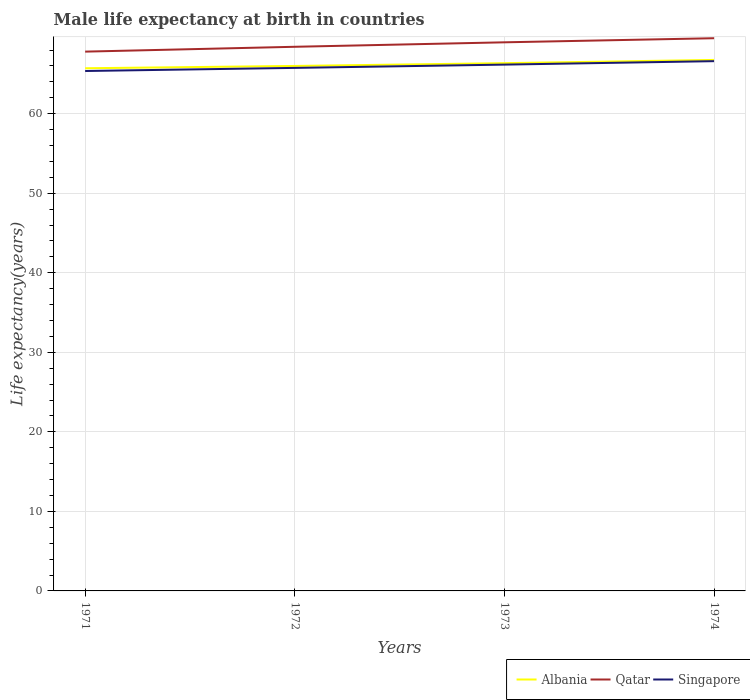Does the line corresponding to Singapore intersect with the line corresponding to Qatar?
Give a very brief answer. No. Across all years, what is the maximum male life expectancy at birth in Singapore?
Your answer should be very brief. 65.37. What is the total male life expectancy at birth in Qatar in the graph?
Keep it short and to the point. -1.08. What is the difference between the highest and the second highest male life expectancy at birth in Singapore?
Your answer should be very brief. 1.24. What is the difference between the highest and the lowest male life expectancy at birth in Qatar?
Offer a very short reply. 2. Is the male life expectancy at birth in Qatar strictly greater than the male life expectancy at birth in Albania over the years?
Offer a terse response. No. How many lines are there?
Your answer should be very brief. 3. How many years are there in the graph?
Provide a short and direct response. 4. Does the graph contain any zero values?
Give a very brief answer. No. Where does the legend appear in the graph?
Your answer should be very brief. Bottom right. How many legend labels are there?
Your answer should be very brief. 3. What is the title of the graph?
Your answer should be compact. Male life expectancy at birth in countries. What is the label or title of the X-axis?
Offer a very short reply. Years. What is the label or title of the Y-axis?
Make the answer very short. Life expectancy(years). What is the Life expectancy(years) of Albania in 1971?
Ensure brevity in your answer.  65.71. What is the Life expectancy(years) of Qatar in 1971?
Provide a succinct answer. 67.8. What is the Life expectancy(years) in Singapore in 1971?
Give a very brief answer. 65.37. What is the Life expectancy(years) in Albania in 1972?
Ensure brevity in your answer.  66. What is the Life expectancy(years) in Qatar in 1972?
Your response must be concise. 68.41. What is the Life expectancy(years) of Singapore in 1972?
Give a very brief answer. 65.76. What is the Life expectancy(years) in Albania in 1973?
Provide a succinct answer. 66.36. What is the Life expectancy(years) in Qatar in 1973?
Provide a succinct answer. 68.97. What is the Life expectancy(years) in Singapore in 1973?
Provide a succinct answer. 66.17. What is the Life expectancy(years) of Albania in 1974?
Provide a succinct answer. 66.76. What is the Life expectancy(years) of Qatar in 1974?
Offer a very short reply. 69.49. What is the Life expectancy(years) of Singapore in 1974?
Provide a succinct answer. 66.61. Across all years, what is the maximum Life expectancy(years) in Albania?
Provide a succinct answer. 66.76. Across all years, what is the maximum Life expectancy(years) of Qatar?
Your answer should be compact. 69.49. Across all years, what is the maximum Life expectancy(years) in Singapore?
Ensure brevity in your answer.  66.61. Across all years, what is the minimum Life expectancy(years) of Albania?
Offer a very short reply. 65.71. Across all years, what is the minimum Life expectancy(years) of Qatar?
Keep it short and to the point. 67.8. Across all years, what is the minimum Life expectancy(years) of Singapore?
Make the answer very short. 65.37. What is the total Life expectancy(years) of Albania in the graph?
Your response must be concise. 264.84. What is the total Life expectancy(years) in Qatar in the graph?
Provide a short and direct response. 274.68. What is the total Life expectancy(years) in Singapore in the graph?
Provide a short and direct response. 263.91. What is the difference between the Life expectancy(years) of Albania in 1971 and that in 1972?
Your answer should be very brief. -0.29. What is the difference between the Life expectancy(years) of Qatar in 1971 and that in 1972?
Offer a terse response. -0.61. What is the difference between the Life expectancy(years) in Singapore in 1971 and that in 1972?
Your answer should be compact. -0.39. What is the difference between the Life expectancy(years) of Albania in 1971 and that in 1973?
Provide a succinct answer. -0.64. What is the difference between the Life expectancy(years) of Qatar in 1971 and that in 1973?
Offer a terse response. -1.17. What is the difference between the Life expectancy(years) of Singapore in 1971 and that in 1973?
Offer a very short reply. -0.8. What is the difference between the Life expectancy(years) of Albania in 1971 and that in 1974?
Make the answer very short. -1.05. What is the difference between the Life expectancy(years) in Qatar in 1971 and that in 1974?
Provide a short and direct response. -1.69. What is the difference between the Life expectancy(years) of Singapore in 1971 and that in 1974?
Your answer should be very brief. -1.24. What is the difference between the Life expectancy(years) of Albania in 1972 and that in 1973?
Give a very brief answer. -0.35. What is the difference between the Life expectancy(years) of Qatar in 1972 and that in 1973?
Ensure brevity in your answer.  -0.56. What is the difference between the Life expectancy(years) of Singapore in 1972 and that in 1973?
Keep it short and to the point. -0.41. What is the difference between the Life expectancy(years) of Albania in 1972 and that in 1974?
Give a very brief answer. -0.76. What is the difference between the Life expectancy(years) of Qatar in 1972 and that in 1974?
Your answer should be compact. -1.08. What is the difference between the Life expectancy(years) of Singapore in 1972 and that in 1974?
Make the answer very short. -0.85. What is the difference between the Life expectancy(years) of Albania in 1973 and that in 1974?
Provide a short and direct response. -0.41. What is the difference between the Life expectancy(years) of Qatar in 1973 and that in 1974?
Provide a succinct answer. -0.52. What is the difference between the Life expectancy(years) in Singapore in 1973 and that in 1974?
Provide a short and direct response. -0.43. What is the difference between the Life expectancy(years) of Albania in 1971 and the Life expectancy(years) of Qatar in 1972?
Offer a very short reply. -2.7. What is the difference between the Life expectancy(years) of Albania in 1971 and the Life expectancy(years) of Singapore in 1972?
Make the answer very short. -0.04. What is the difference between the Life expectancy(years) in Qatar in 1971 and the Life expectancy(years) in Singapore in 1972?
Provide a succinct answer. 2.04. What is the difference between the Life expectancy(years) in Albania in 1971 and the Life expectancy(years) in Qatar in 1973?
Your response must be concise. -3.26. What is the difference between the Life expectancy(years) of Albania in 1971 and the Life expectancy(years) of Singapore in 1973?
Keep it short and to the point. -0.46. What is the difference between the Life expectancy(years) of Qatar in 1971 and the Life expectancy(years) of Singapore in 1973?
Provide a succinct answer. 1.63. What is the difference between the Life expectancy(years) in Albania in 1971 and the Life expectancy(years) in Qatar in 1974?
Provide a succinct answer. -3.78. What is the difference between the Life expectancy(years) in Albania in 1971 and the Life expectancy(years) in Singapore in 1974?
Your response must be concise. -0.89. What is the difference between the Life expectancy(years) in Qatar in 1971 and the Life expectancy(years) in Singapore in 1974?
Make the answer very short. 1.2. What is the difference between the Life expectancy(years) of Albania in 1972 and the Life expectancy(years) of Qatar in 1973?
Your response must be concise. -2.97. What is the difference between the Life expectancy(years) in Albania in 1972 and the Life expectancy(years) in Singapore in 1973?
Offer a very short reply. -0.17. What is the difference between the Life expectancy(years) of Qatar in 1972 and the Life expectancy(years) of Singapore in 1973?
Provide a short and direct response. 2.24. What is the difference between the Life expectancy(years) of Albania in 1972 and the Life expectancy(years) of Qatar in 1974?
Make the answer very short. -3.49. What is the difference between the Life expectancy(years) of Albania in 1972 and the Life expectancy(years) of Singapore in 1974?
Keep it short and to the point. -0.6. What is the difference between the Life expectancy(years) of Qatar in 1972 and the Life expectancy(years) of Singapore in 1974?
Provide a succinct answer. 1.81. What is the difference between the Life expectancy(years) of Albania in 1973 and the Life expectancy(years) of Qatar in 1974?
Your answer should be very brief. -3.13. What is the difference between the Life expectancy(years) of Qatar in 1973 and the Life expectancy(years) of Singapore in 1974?
Offer a terse response. 2.37. What is the average Life expectancy(years) of Albania per year?
Offer a terse response. 66.21. What is the average Life expectancy(years) of Qatar per year?
Your answer should be compact. 68.67. What is the average Life expectancy(years) in Singapore per year?
Offer a very short reply. 65.98. In the year 1971, what is the difference between the Life expectancy(years) in Albania and Life expectancy(years) in Qatar?
Your response must be concise. -2.09. In the year 1971, what is the difference between the Life expectancy(years) of Albania and Life expectancy(years) of Singapore?
Provide a succinct answer. 0.34. In the year 1971, what is the difference between the Life expectancy(years) of Qatar and Life expectancy(years) of Singapore?
Give a very brief answer. 2.44. In the year 1972, what is the difference between the Life expectancy(years) in Albania and Life expectancy(years) in Qatar?
Provide a succinct answer. -2.41. In the year 1972, what is the difference between the Life expectancy(years) of Albania and Life expectancy(years) of Singapore?
Make the answer very short. 0.24. In the year 1972, what is the difference between the Life expectancy(years) of Qatar and Life expectancy(years) of Singapore?
Offer a very short reply. 2.65. In the year 1973, what is the difference between the Life expectancy(years) of Albania and Life expectancy(years) of Qatar?
Your answer should be very brief. -2.62. In the year 1973, what is the difference between the Life expectancy(years) in Albania and Life expectancy(years) in Singapore?
Keep it short and to the point. 0.18. In the year 1973, what is the difference between the Life expectancy(years) of Qatar and Life expectancy(years) of Singapore?
Offer a terse response. 2.8. In the year 1974, what is the difference between the Life expectancy(years) of Albania and Life expectancy(years) of Qatar?
Provide a short and direct response. -2.73. In the year 1974, what is the difference between the Life expectancy(years) of Albania and Life expectancy(years) of Singapore?
Offer a terse response. 0.16. In the year 1974, what is the difference between the Life expectancy(years) of Qatar and Life expectancy(years) of Singapore?
Your answer should be compact. 2.88. What is the ratio of the Life expectancy(years) of Singapore in 1971 to that in 1972?
Offer a very short reply. 0.99. What is the ratio of the Life expectancy(years) in Albania in 1971 to that in 1973?
Keep it short and to the point. 0.99. What is the ratio of the Life expectancy(years) of Qatar in 1971 to that in 1973?
Provide a short and direct response. 0.98. What is the ratio of the Life expectancy(years) in Singapore in 1971 to that in 1973?
Provide a short and direct response. 0.99. What is the ratio of the Life expectancy(years) of Albania in 1971 to that in 1974?
Your answer should be compact. 0.98. What is the ratio of the Life expectancy(years) in Qatar in 1971 to that in 1974?
Your answer should be compact. 0.98. What is the ratio of the Life expectancy(years) of Singapore in 1971 to that in 1974?
Ensure brevity in your answer.  0.98. What is the ratio of the Life expectancy(years) of Albania in 1972 to that in 1973?
Provide a short and direct response. 0.99. What is the ratio of the Life expectancy(years) in Qatar in 1972 to that in 1973?
Provide a short and direct response. 0.99. What is the ratio of the Life expectancy(years) of Qatar in 1972 to that in 1974?
Your answer should be very brief. 0.98. What is the ratio of the Life expectancy(years) of Singapore in 1972 to that in 1974?
Your response must be concise. 0.99. What is the ratio of the Life expectancy(years) of Albania in 1973 to that in 1974?
Ensure brevity in your answer.  0.99. What is the ratio of the Life expectancy(years) in Qatar in 1973 to that in 1974?
Your answer should be very brief. 0.99. What is the difference between the highest and the second highest Life expectancy(years) in Albania?
Ensure brevity in your answer.  0.41. What is the difference between the highest and the second highest Life expectancy(years) of Qatar?
Your answer should be compact. 0.52. What is the difference between the highest and the second highest Life expectancy(years) of Singapore?
Your answer should be very brief. 0.43. What is the difference between the highest and the lowest Life expectancy(years) in Albania?
Offer a very short reply. 1.05. What is the difference between the highest and the lowest Life expectancy(years) of Qatar?
Give a very brief answer. 1.69. What is the difference between the highest and the lowest Life expectancy(years) in Singapore?
Offer a very short reply. 1.24. 